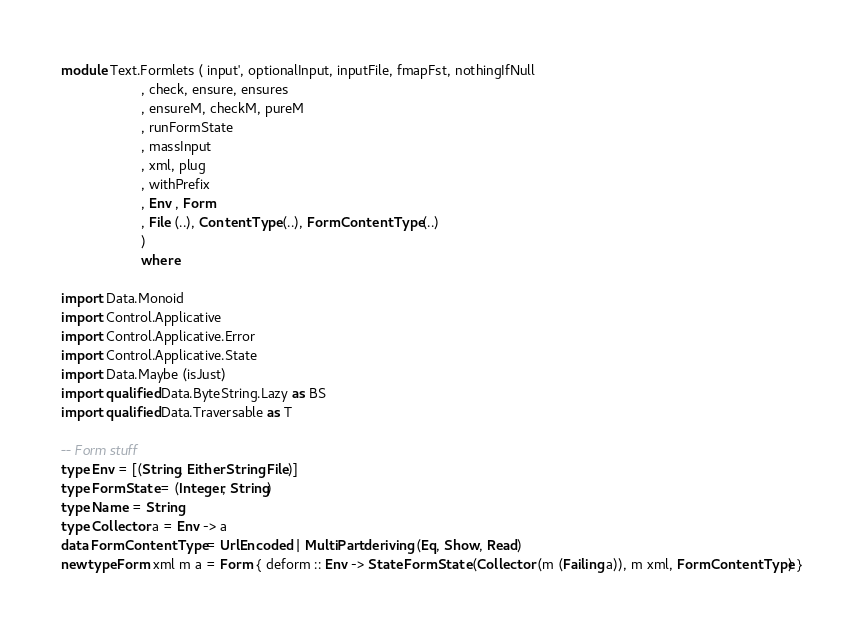Convert code to text. <code><loc_0><loc_0><loc_500><loc_500><_Haskell_>module Text.Formlets ( input', optionalInput, inputFile, fmapFst, nothingIfNull
                     , check, ensure, ensures
                     , ensureM, checkM, pureM
                     , runFormState 
                     , massInput
                     , xml, plug
                     , withPrefix
                     , Env , Form
                     , File (..), ContentType (..), FormContentType (..)
                     )
                     where

import Data.Monoid
import Control.Applicative
import Control.Applicative.Error
import Control.Applicative.State
import Data.Maybe (isJust)
import qualified Data.ByteString.Lazy as BS
import qualified Data.Traversable as T

-- Form stuff
type Env = [(String, Either String File)]
type FormState = (Integer, String)
type Name = String
type Collector a = Env -> a
data FormContentType = UrlEncoded | MultiPart deriving (Eq, Show, Read)
newtype Form xml m a = Form { deform :: Env -> State FormState (Collector (m (Failing a)), m xml, FormContentType) }</code> 